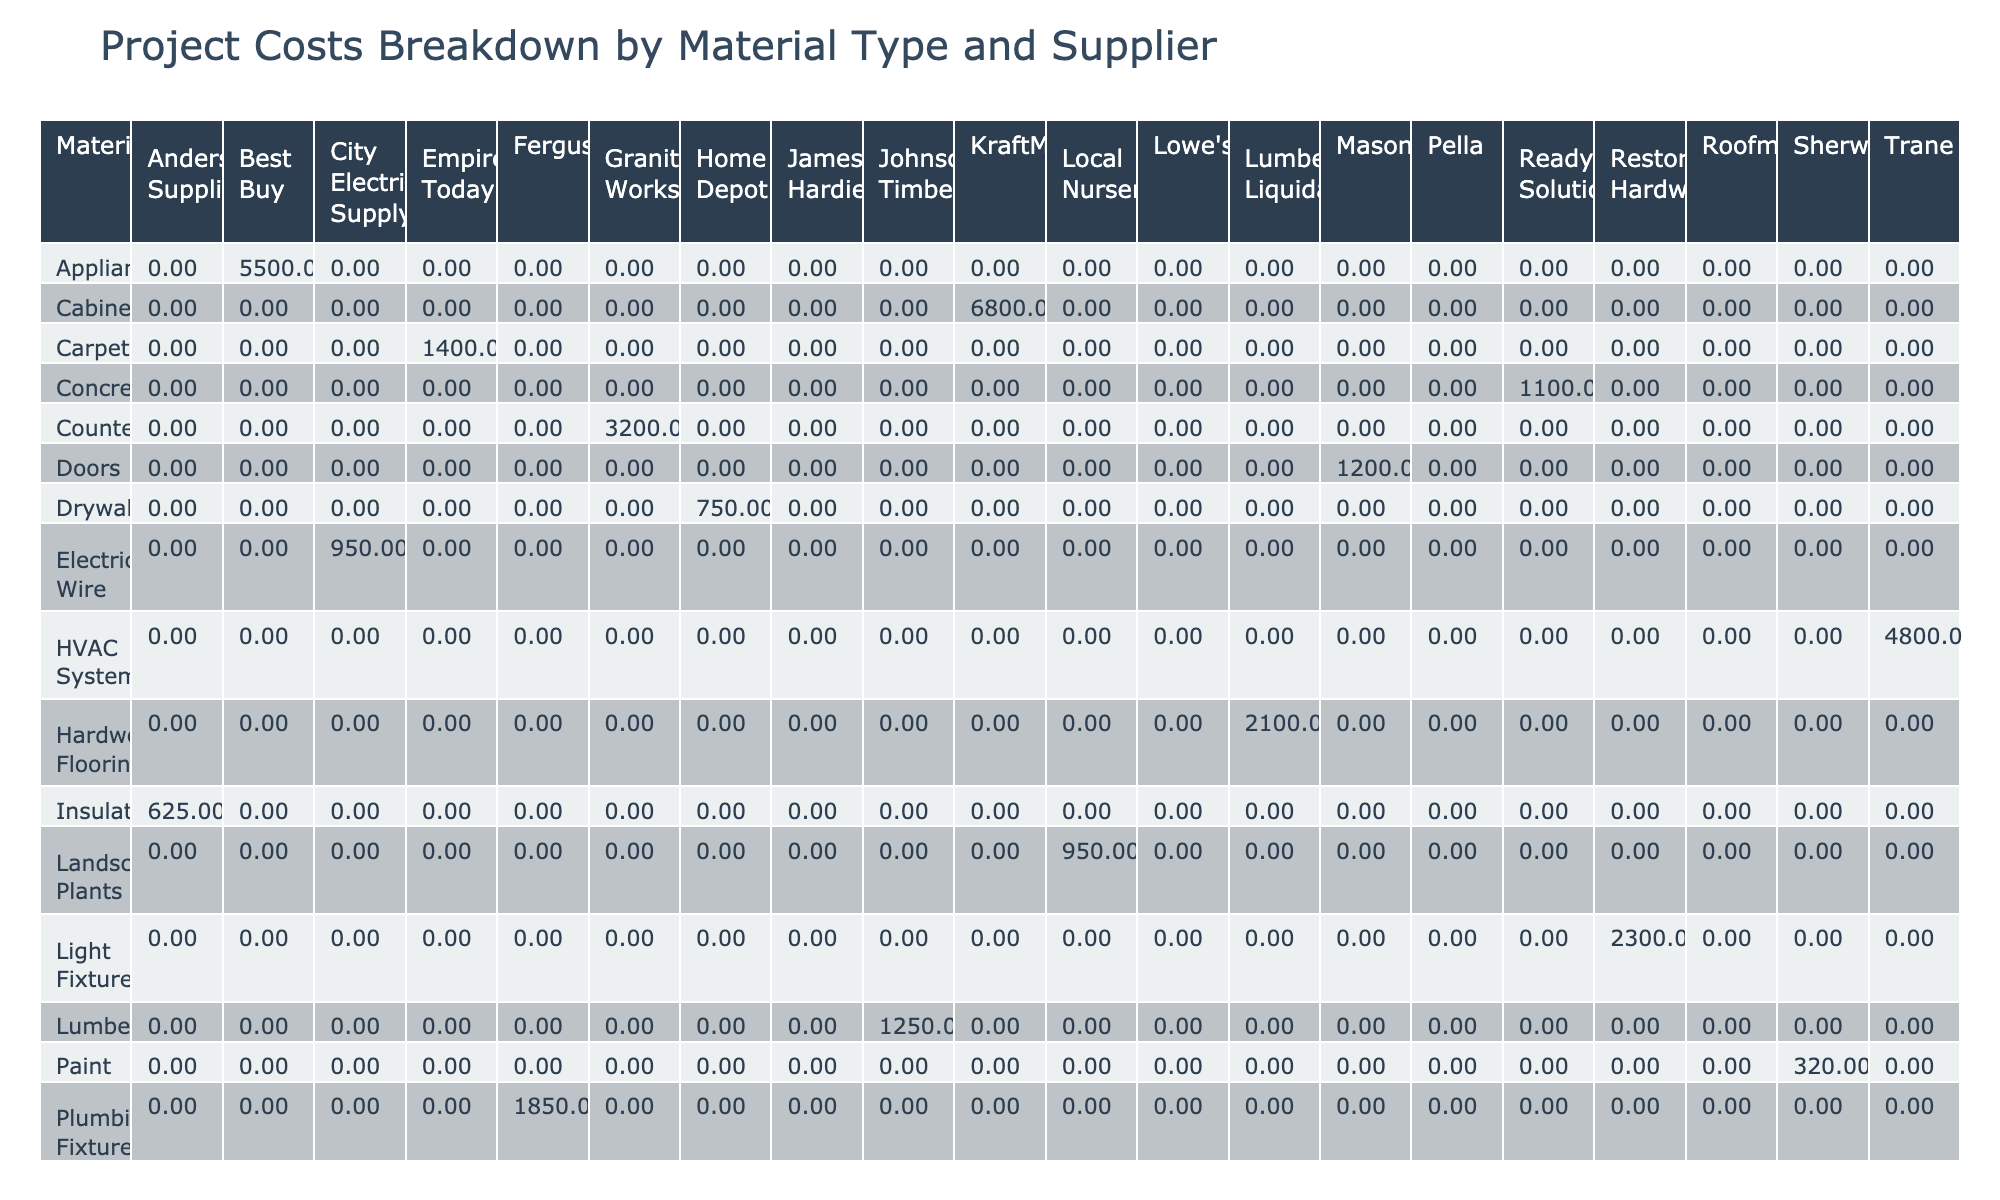What is the total cost of materials supplied by Home Depot? From the table, the only material supplied by Home Depot is Drywall, which costs 750.00. Therefore, the total cost from this supplier is simply 750.00.
Answer: 750.00 Which material has the highest cost, and who is the supplier? By examining the table, the highest cost is for Cabinets at 6800.00, with the supplier being KraftMaid.
Answer: Cabinets, KraftMaid How much more does it cost to replace the windows compared to roofing shingles? The cost for Windows is 4500.00 and for Roofing Shingles, it is 3200.00. The difference is calculated as 4500.00 - 3200.00 = 1300.00.
Answer: 1300.00 Are there any materials provided by Johnson's Timber? Yes, the table shows that Lumber is supplied by Johnson's Timber.
Answer: Yes What is the average cost per unit of all materials provided by Pella? Pella supplies only Windows at a cost of 4500.00 for 6 units. To calculate the average cost per unit, divide the total cost by the quantity: 4500.00 / 6 = 750.00.
Answer: 750.00 Which supplier provides plumbing fixtures and how much do they cost? The table specifies that Ferguson supplies Plumbing Fixtures, and they cost 1850.00.
Answer: Ferguson, 1850.00 What is the total cost of materials supplied by Trane and ReadyMix Solutions combined? Trane supplies an HVAC System costing 4800.00, while ReadyMix Solutions provides Concrete for 1100.00. Combining these gives: 4800.00 + 1100.00 = 5900.00.
Answer: 5900.00 Is there any material that costs less than 500.00? No materials in the table are listed at a cost less than 500.00.
Answer: No What are the total costs of materials for Kitchen Remodels, and which suppliers are involved? The Kitchen Remodel involves Lumber from Johnson's Timber (1250.00) and Countertops from Granite Works (3200.00). Adding these costs gives: 1250.00 + 3200.00 = 4450.00.
Answer: 4450.00 